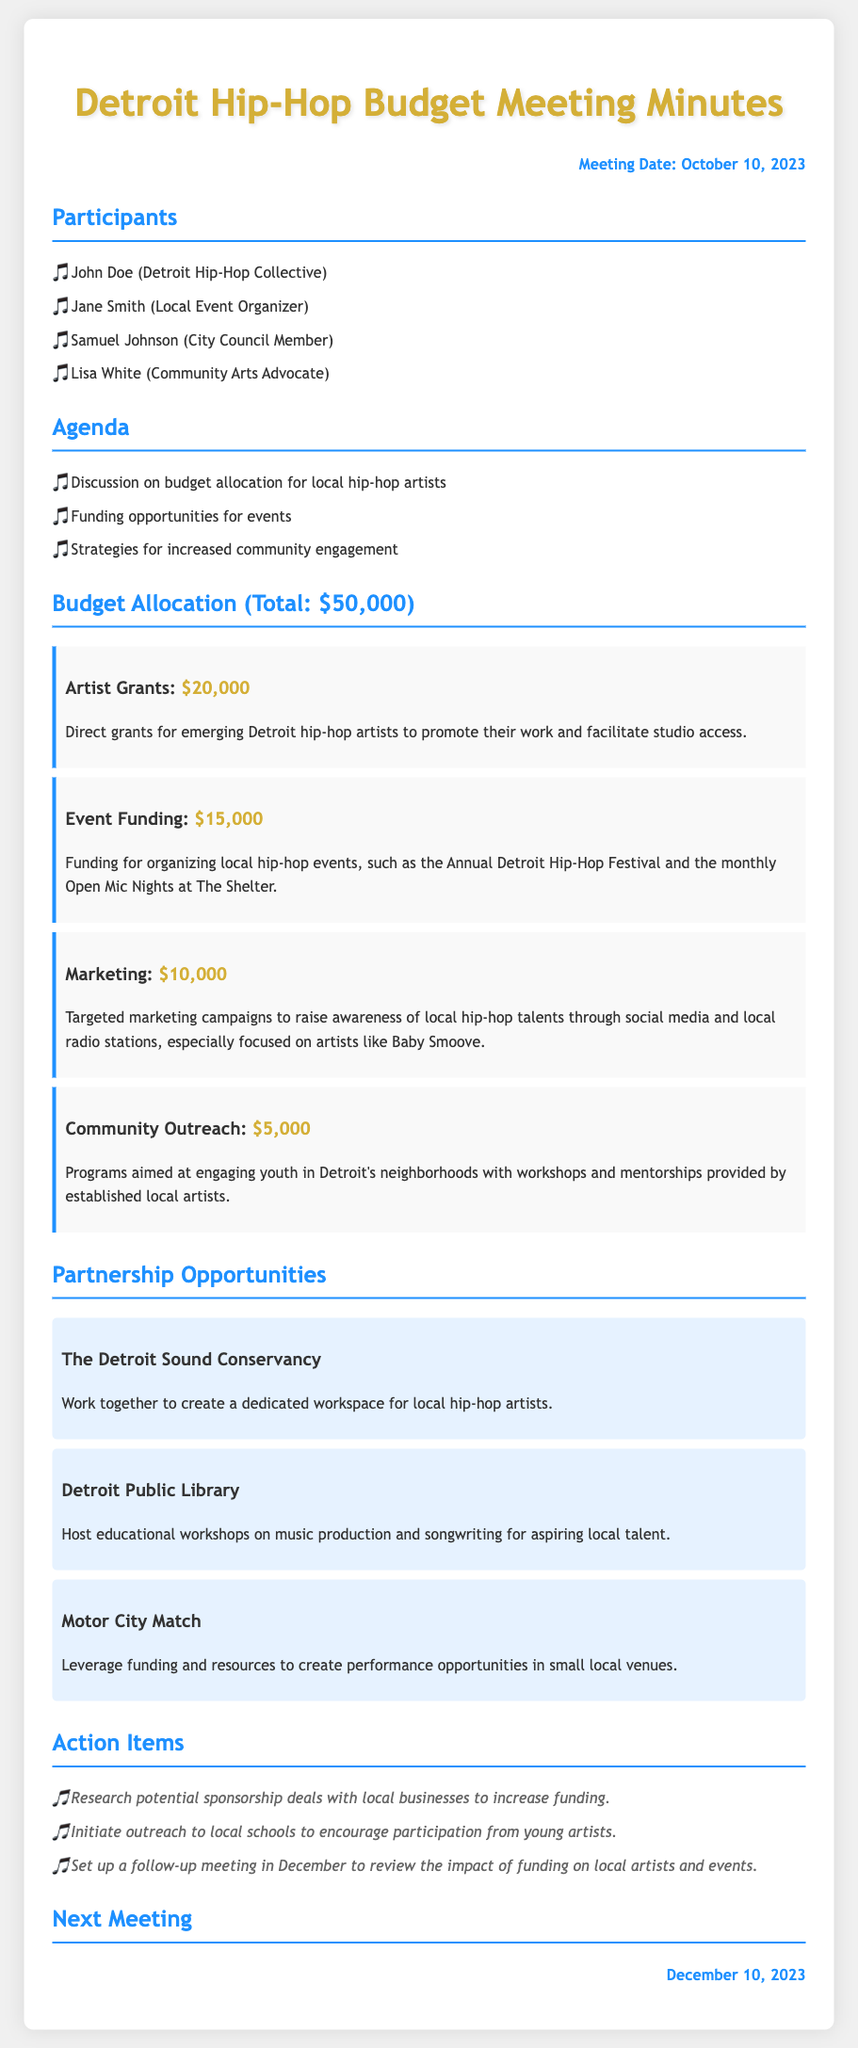What is the total budget allocated for local hip-hop initiatives? The total budget allocated is outlined in the document under "Budget Allocation," specifically mentioned as $50,000.
Answer: $50,000 How much funding is designated for artist grants? The amount allocated for artist grants can be found under the "Budget Allocation" section, where it specifies $20,000 for artist grants.
Answer: $20,000 What event is funded with $15,000? The funding for events specifically includes the Annual Detroit Hip-Hop Festival, as highlighted in the budget details for Event Funding.
Answer: Annual Detroit Hip-Hop Festival Who is listed as a participant from the City Council? The document includes Samuel Johnson as the representative from the City Council among the participants.
Answer: Samuel Johnson What is one of the partnership opportunities mentioned? The document lists several partnerships; one of them is with "The Detroit Sound Conservancy," which is highlighted in the Partnership Opportunities section.
Answer: The Detroit Sound Conservancy What is the date of the next meeting? The next meeting date is provided at the end of the document, listed as December 10, 2023.
Answer: December 10, 2023 What is the budget amount allocated for marketing? The document specifies the amount for marketing in the "Budget Allocation" section as $10,000.
Answer: $10,000 Which action item involves local schools? An action item in the document specifically mentions initiating outreach to local schools, detailing efforts to engage young artists.
Answer: Initiate outreach to local schools How much is allocated for community outreach programs? The amount designated for community outreach is clearly stated as $5,000 in the budget allocation details.
Answer: $5,000 